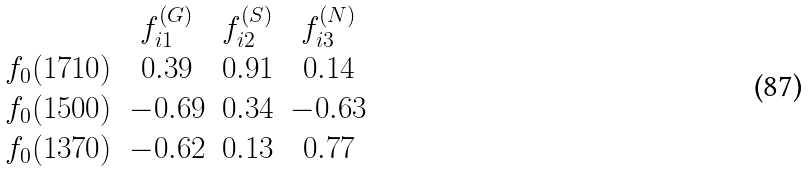<formula> <loc_0><loc_0><loc_500><loc_500>\begin{array} { c c c c } & f _ { i 1 } ^ { ( G ) } & f _ { i 2 } ^ { ( S ) } & f _ { i 3 } ^ { ( N ) } \\ f _ { 0 } ( 1 7 1 0 ) & 0 . 3 9 & 0 . 9 1 & 0 . 1 4 \\ f _ { 0 } ( 1 5 0 0 ) & - 0 . 6 9 & 0 . 3 4 & - 0 . 6 3 \\ f _ { 0 } ( 1 3 7 0 ) & - 0 . 6 2 & 0 . 1 3 & 0 . 7 7 \\ \end{array}</formula> 